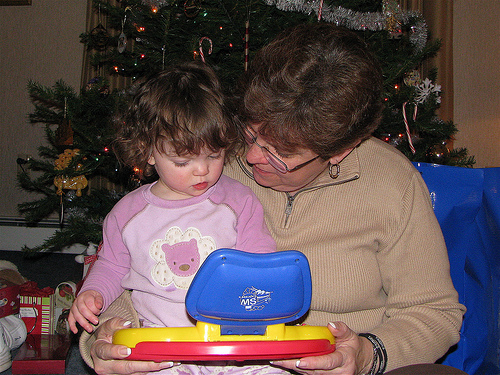<image>
Can you confirm if the woman is under the christmas tree? No. The woman is not positioned under the christmas tree. The vertical relationship between these objects is different. Where is the girl in relation to the woman? Is it on the woman? Yes. Looking at the image, I can see the girl is positioned on top of the woman, with the woman providing support. 